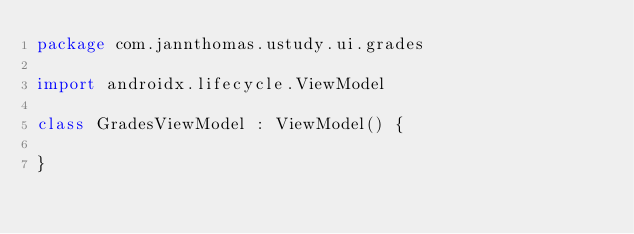<code> <loc_0><loc_0><loc_500><loc_500><_Kotlin_>package com.jannthomas.ustudy.ui.grades

import androidx.lifecycle.ViewModel

class GradesViewModel : ViewModel() {

}</code> 